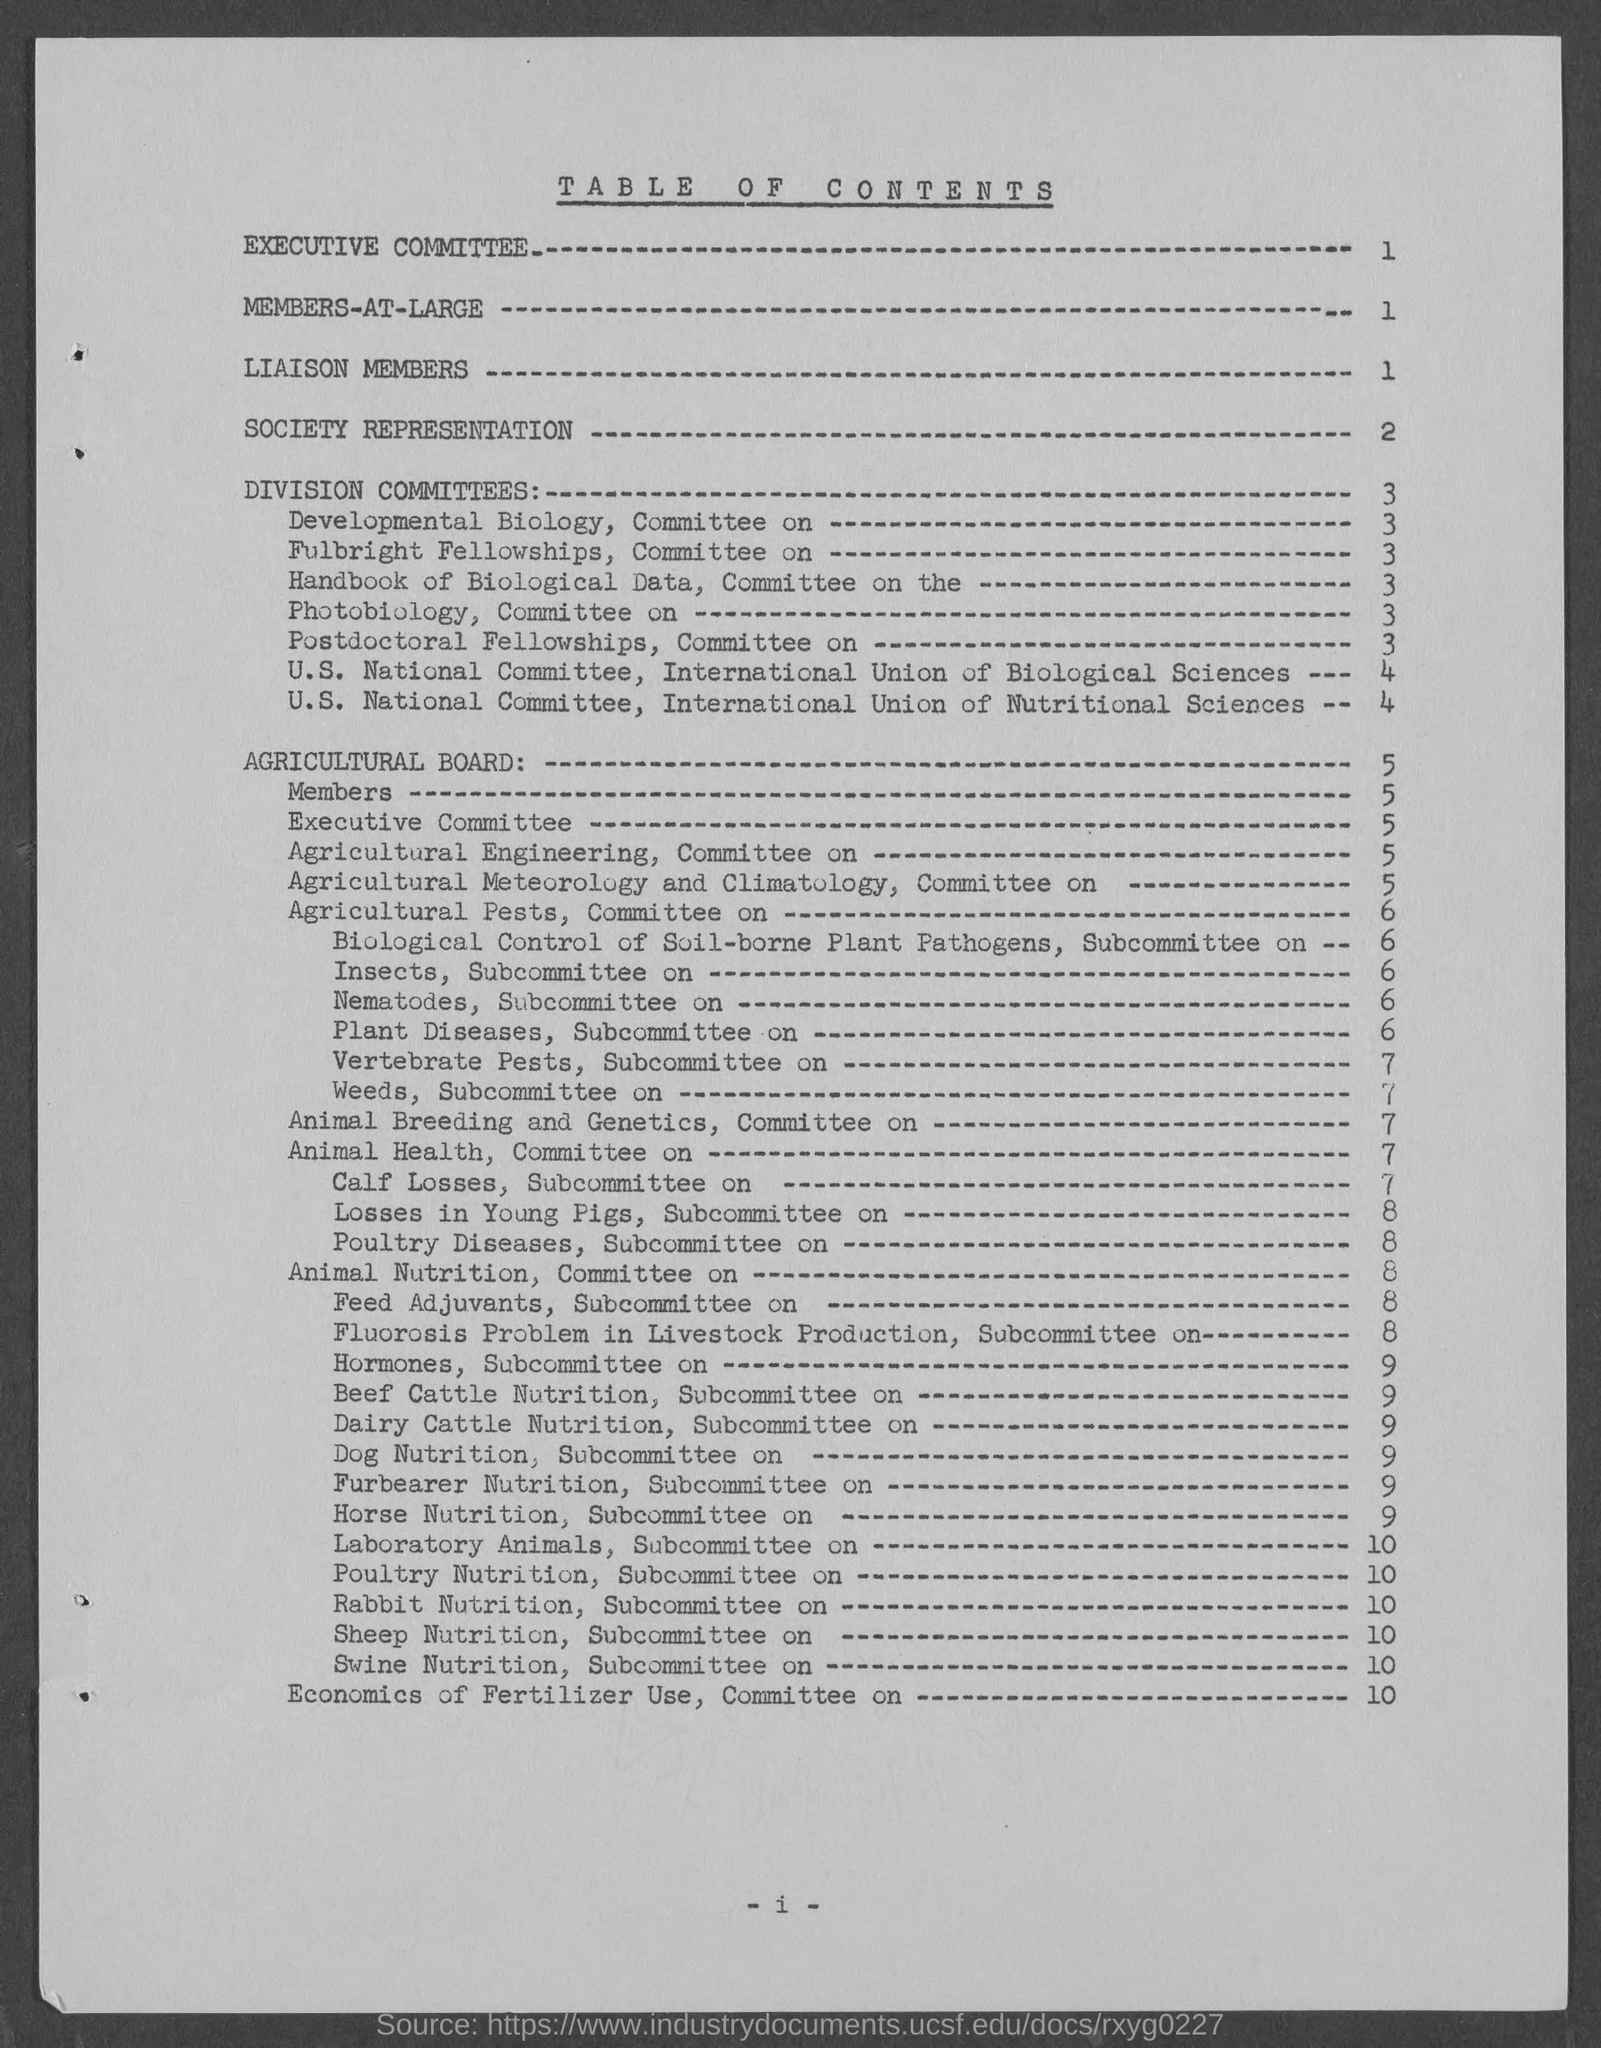On which page number does the title "Society Representation" come?
Provide a short and direct response. 2. 